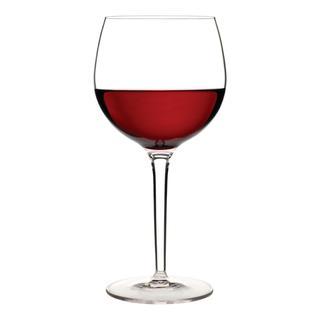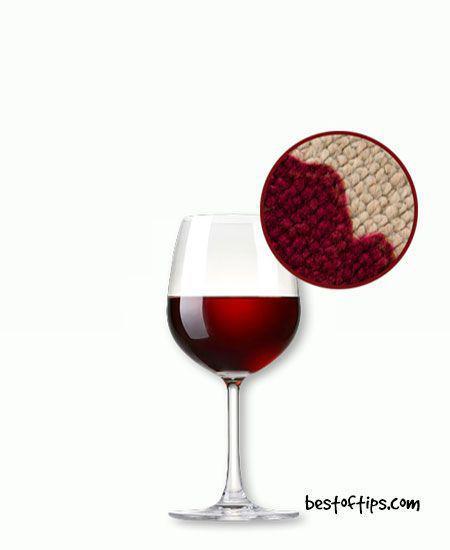The first image is the image on the left, the second image is the image on the right. For the images shown, is this caption "At least one of the images shows liquid in a glass that is stationary and not moving." true? Answer yes or no. Yes. 